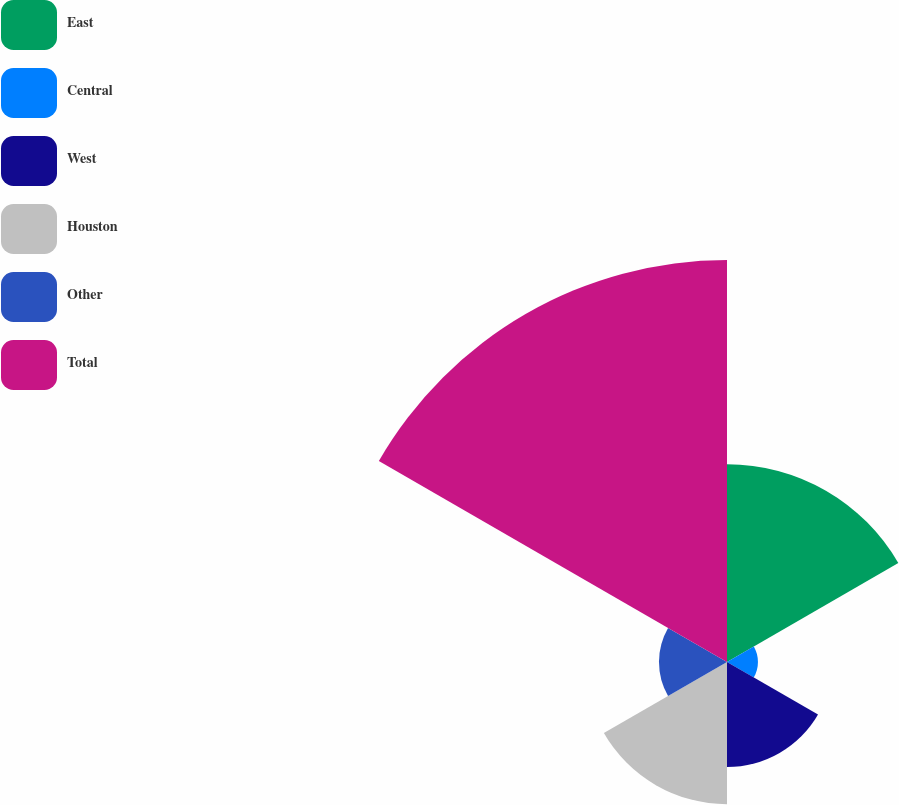Convert chart to OTSL. <chart><loc_0><loc_0><loc_500><loc_500><pie_chart><fcel>East<fcel>Central<fcel>West<fcel>Houston<fcel>Other<fcel>Total<nl><fcel>20.91%<fcel>3.27%<fcel>11.11%<fcel>15.03%<fcel>7.19%<fcel>42.49%<nl></chart> 